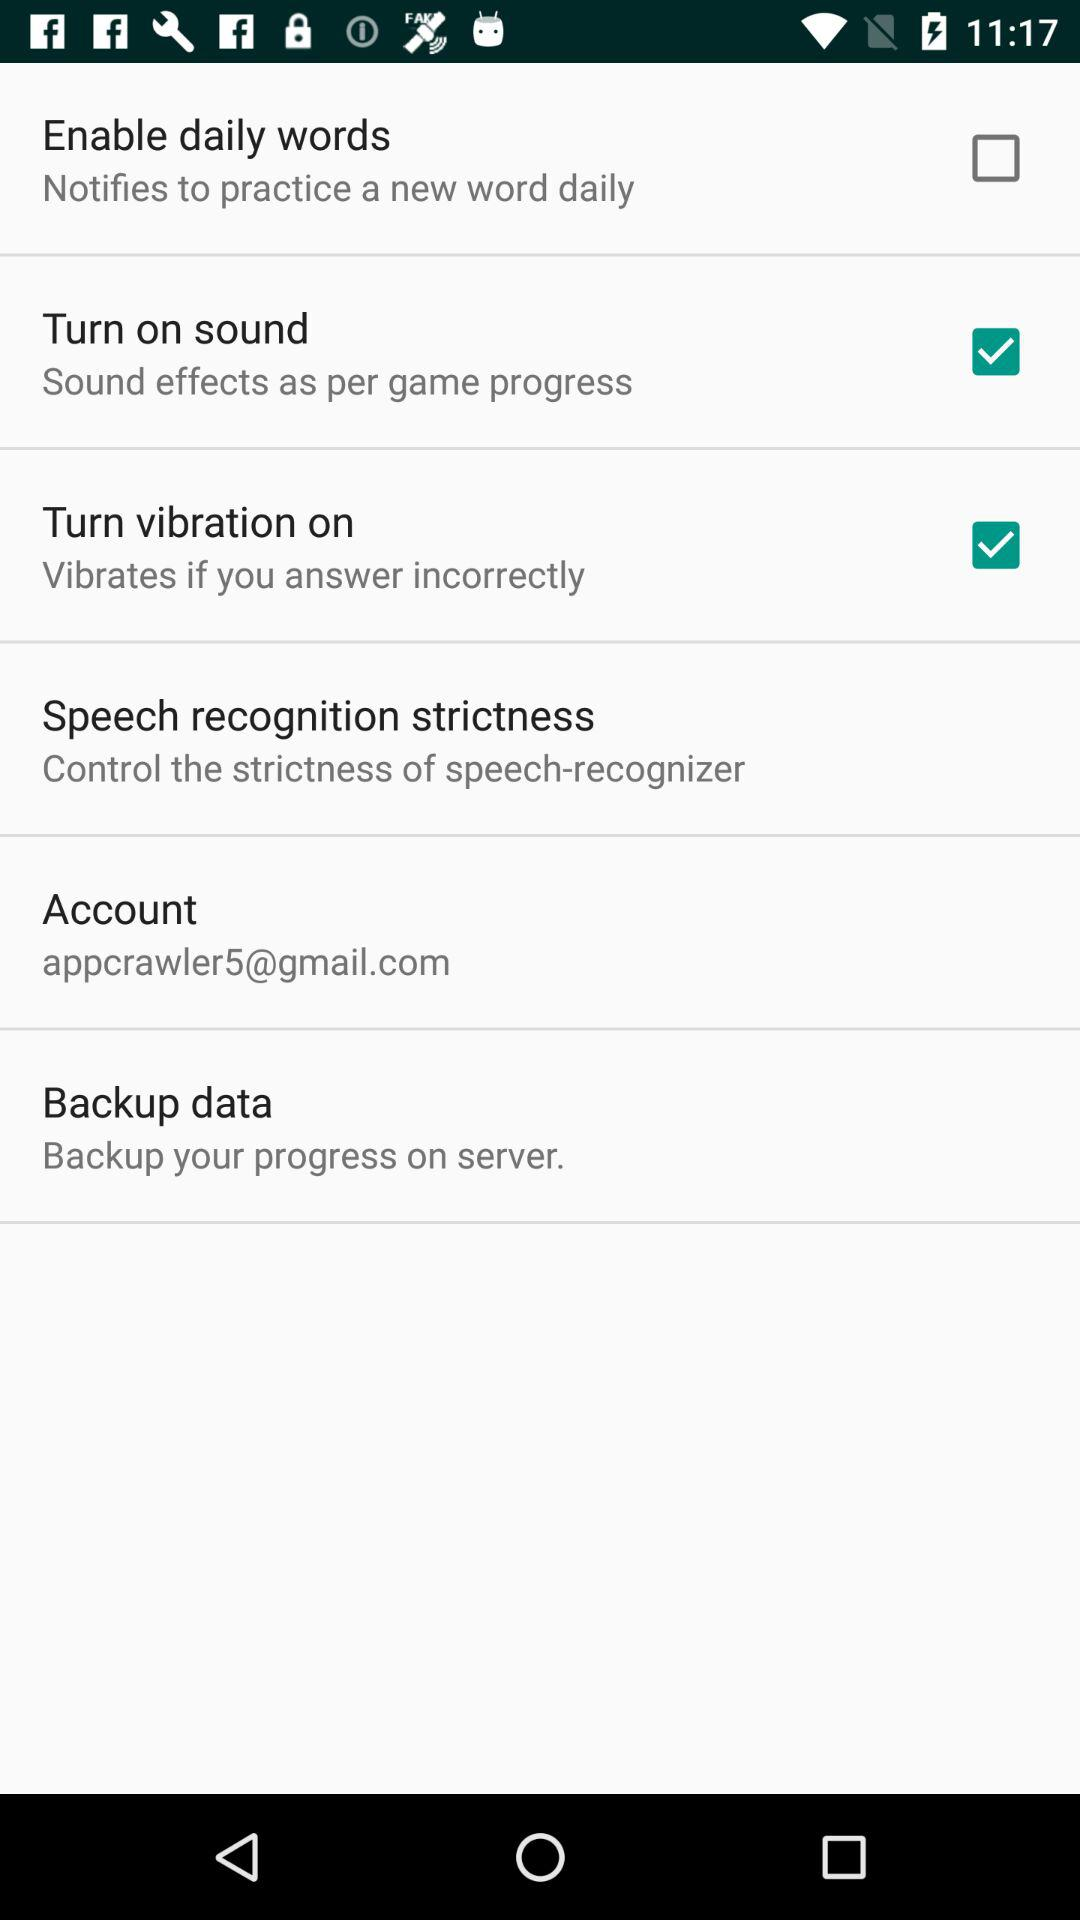What is the status of turn vibration on? The status is on. 